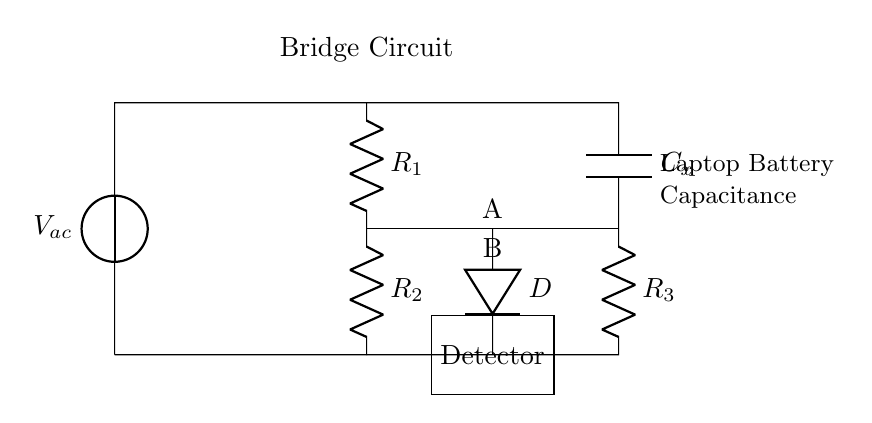What type of circuit is shown? The circuit is a bridge circuit, which is characterized by its configuration that includes resistors and a capacitor arranged to measure unknown capacitance in relation to known components.
Answer: Bridge circuit What is the role of the component labeled D? Component D is a detector, which is used to measure the balance of the bridge circuit by detecting the potential difference or current at point A and B.
Answer: Detector What does the symbol C represent in the circuit? The symbol C represents a capacitor, specifically the unknown capacitance being tested in the laptop battery.
Answer: Capacitor How many resistors are present in the circuit? There are three resistors labeled R1, R2, and R3 in the circuit.
Answer: Three What is the purpose of the voltage source labeled V_ac? The voltage source V_ac provides the alternating current necessary to operate the bridge circuit and facilitate the measurement of capacitance.
Answer: Alternating current What would happen if the bridge is balanced? If the bridge is balanced, the detector will indicate zero voltage or current, indicating that the unknown capacitance is equal to the known capacitances in the circuit.
Answer: Zero voltage Which component indicates the capacitance value? The capacitance value is indicated by the detection at point B in relation to point A, where the bridge balance is assessed.
Answer: Point B 